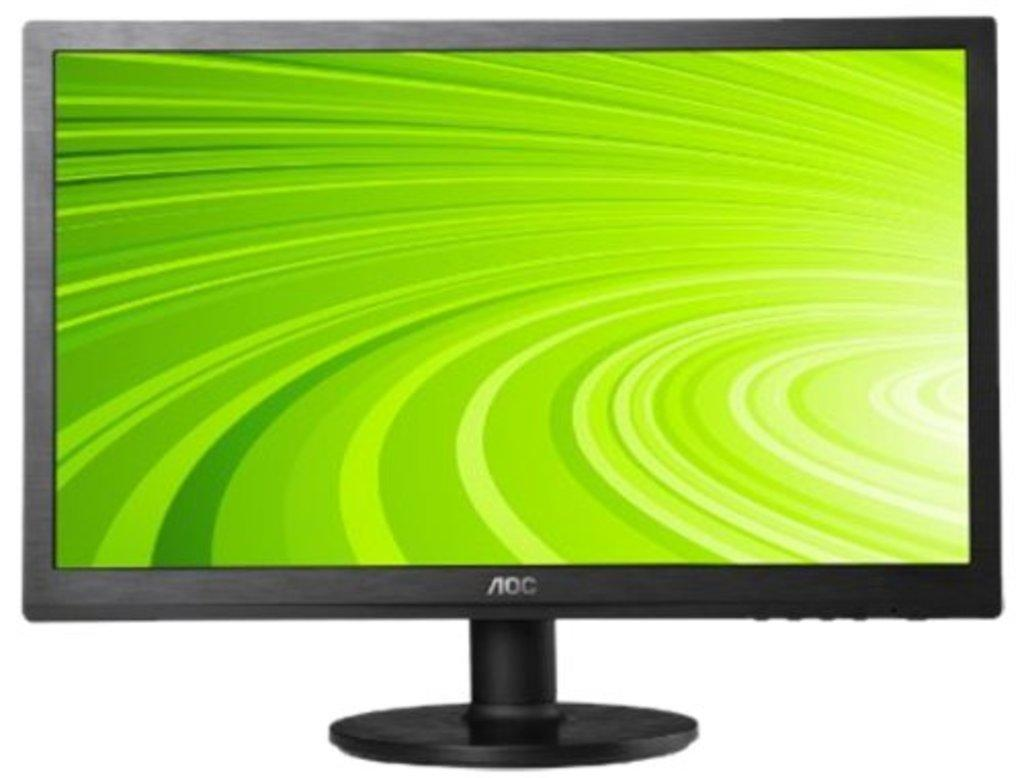<image>
Describe the image concisely. A computer monitor says AOC and has a green wallpaper on the screen. 